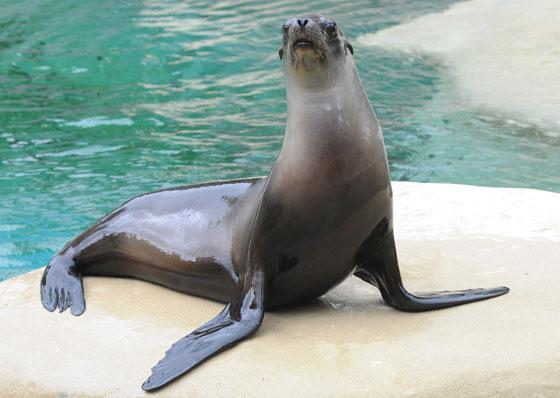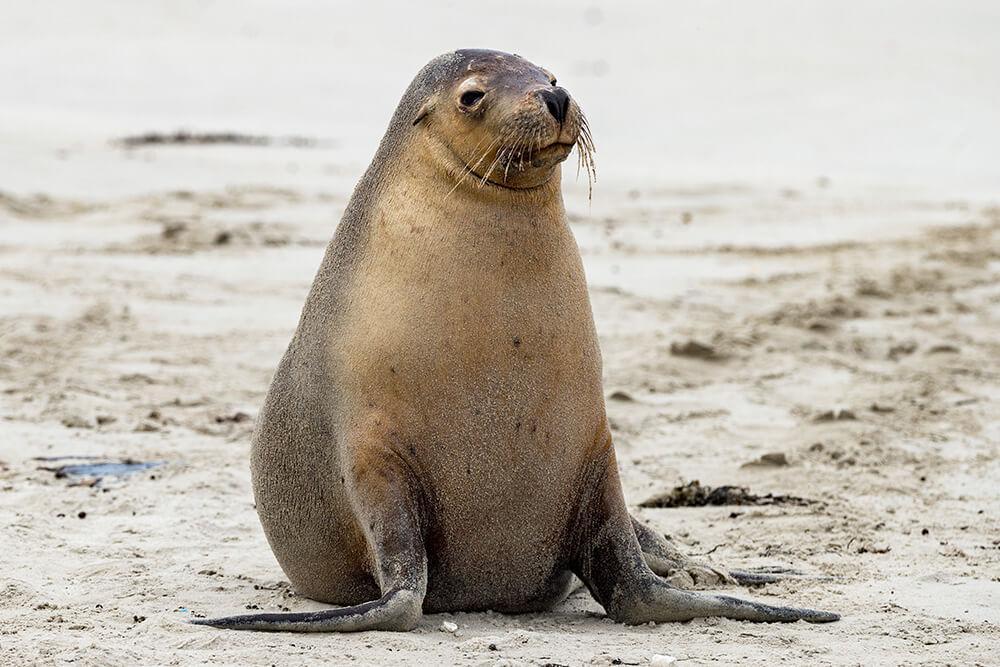The first image is the image on the left, the second image is the image on the right. Evaluate the accuracy of this statement regarding the images: "One image shows a seal on sand without water clearly visible.". Is it true? Answer yes or no. Yes. The first image is the image on the left, the second image is the image on the right. Examine the images to the left and right. Is the description "Blue water is visible in both images of seals." accurate? Answer yes or no. No. 